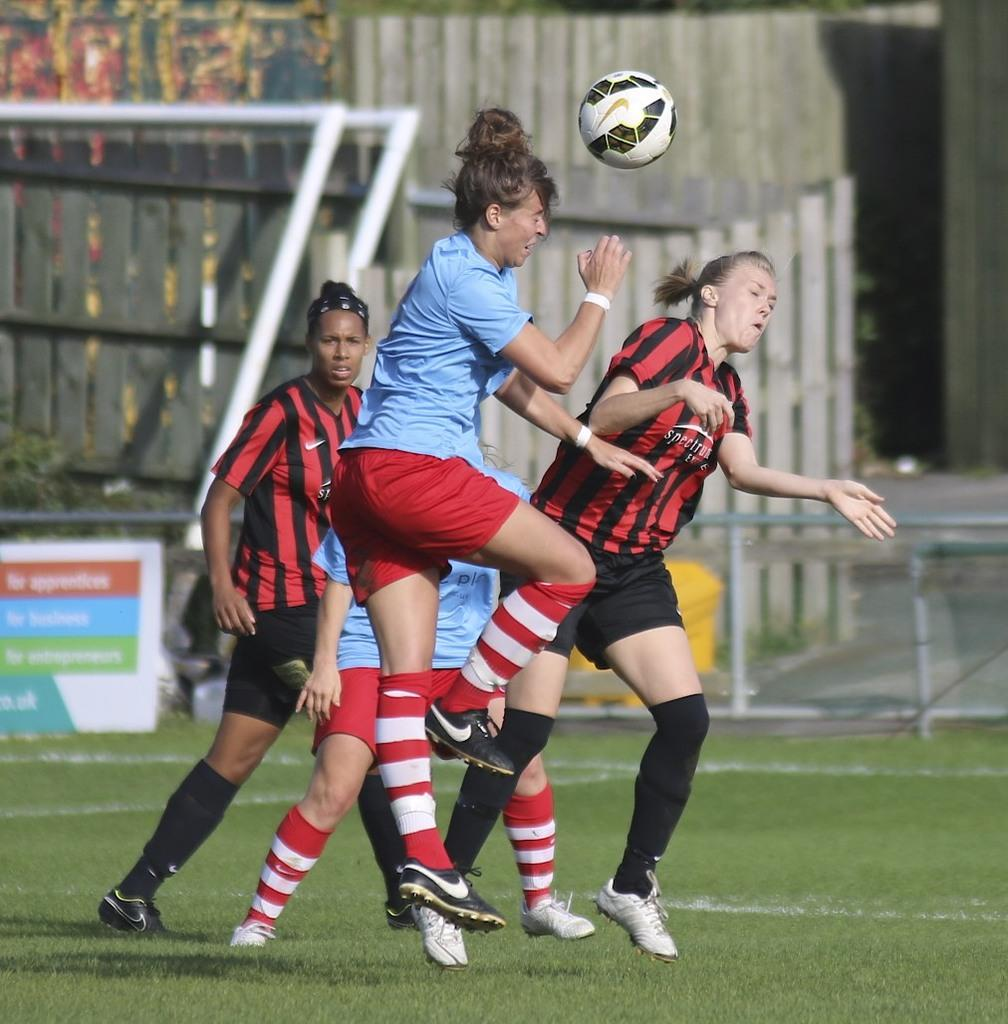How many people are in the image? There is a group of people in the image, but the exact number is not specified. What are the people doing in the image? The people are on the ground, but their specific activity is not mentioned. What object is present in the image along with the people? There is a ball in the image. Is there a river flowing through the image? No, there is no mention of a river in the image. What type of loaf is being used by the people in the image? There is no loaf present in the image. 